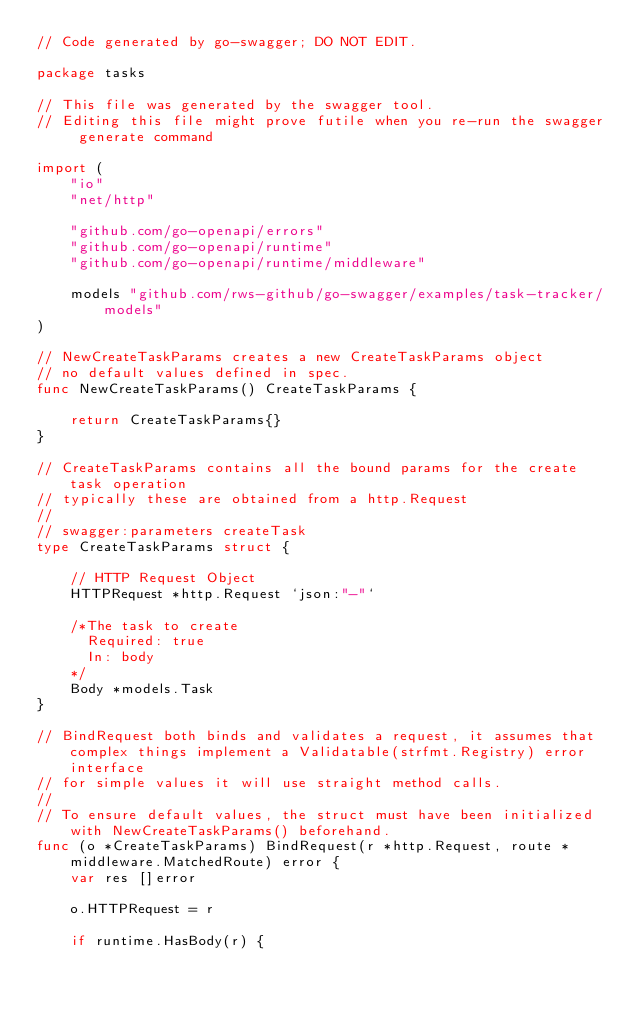Convert code to text. <code><loc_0><loc_0><loc_500><loc_500><_Go_>// Code generated by go-swagger; DO NOT EDIT.

package tasks

// This file was generated by the swagger tool.
// Editing this file might prove futile when you re-run the swagger generate command

import (
	"io"
	"net/http"

	"github.com/go-openapi/errors"
	"github.com/go-openapi/runtime"
	"github.com/go-openapi/runtime/middleware"

	models "github.com/rws-github/go-swagger/examples/task-tracker/models"
)

// NewCreateTaskParams creates a new CreateTaskParams object
// no default values defined in spec.
func NewCreateTaskParams() CreateTaskParams {

	return CreateTaskParams{}
}

// CreateTaskParams contains all the bound params for the create task operation
// typically these are obtained from a http.Request
//
// swagger:parameters createTask
type CreateTaskParams struct {

	// HTTP Request Object
	HTTPRequest *http.Request `json:"-"`

	/*The task to create
	  Required: true
	  In: body
	*/
	Body *models.Task
}

// BindRequest both binds and validates a request, it assumes that complex things implement a Validatable(strfmt.Registry) error interface
// for simple values it will use straight method calls.
//
// To ensure default values, the struct must have been initialized with NewCreateTaskParams() beforehand.
func (o *CreateTaskParams) BindRequest(r *http.Request, route *middleware.MatchedRoute) error {
	var res []error

	o.HTTPRequest = r

	if runtime.HasBody(r) {</code> 